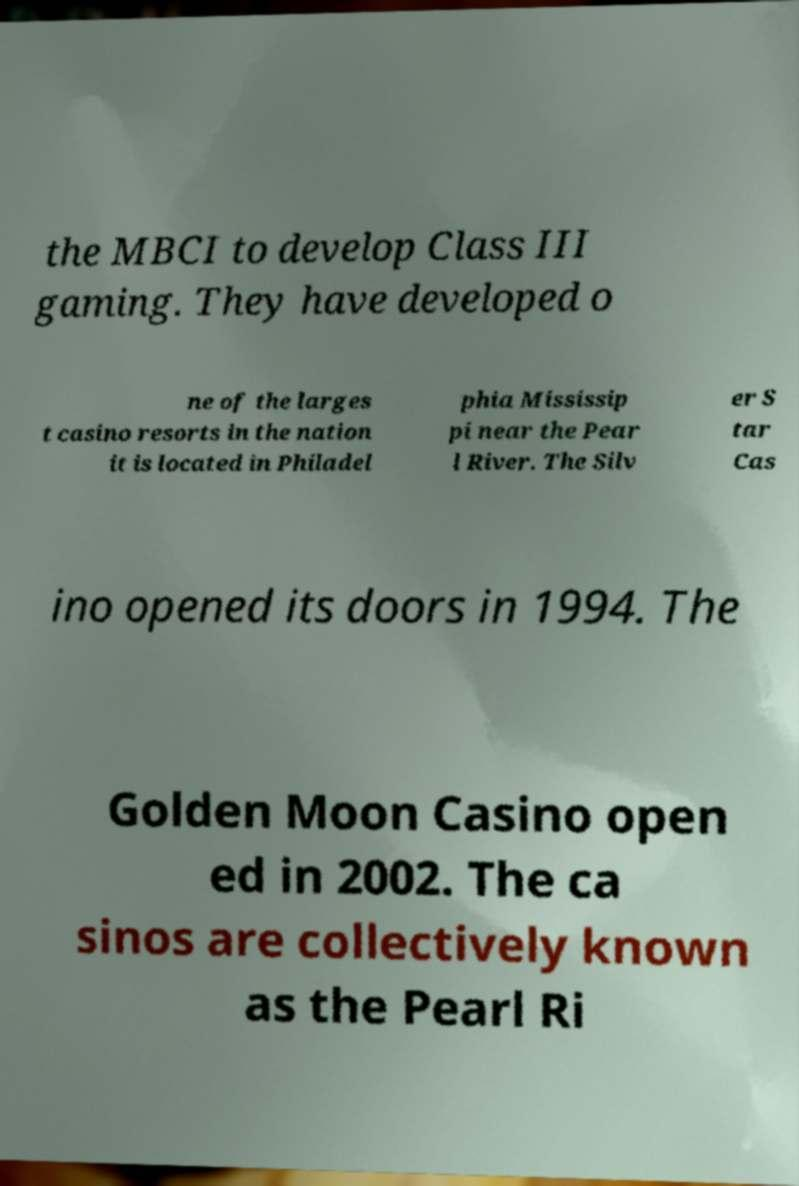There's text embedded in this image that I need extracted. Can you transcribe it verbatim? the MBCI to develop Class III gaming. They have developed o ne of the larges t casino resorts in the nation it is located in Philadel phia Mississip pi near the Pear l River. The Silv er S tar Cas ino opened its doors in 1994. The Golden Moon Casino open ed in 2002. The ca sinos are collectively known as the Pearl Ri 